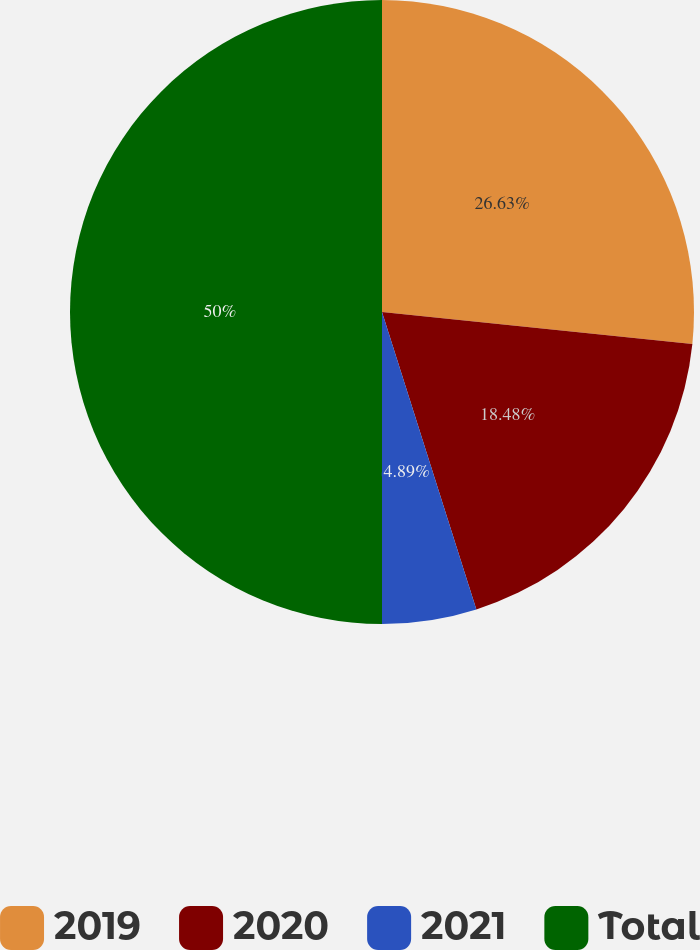Convert chart to OTSL. <chart><loc_0><loc_0><loc_500><loc_500><pie_chart><fcel>2019<fcel>2020<fcel>2021<fcel>Total<nl><fcel>26.63%<fcel>18.48%<fcel>4.89%<fcel>50.0%<nl></chart> 